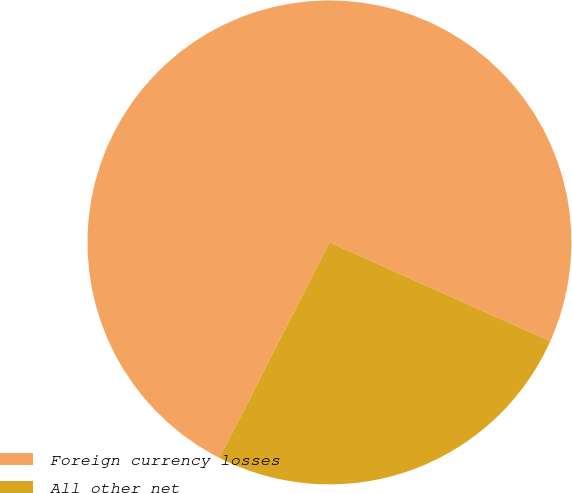<chart> <loc_0><loc_0><loc_500><loc_500><pie_chart><fcel>Foreign currency losses<fcel>All other net<nl><fcel>74.18%<fcel>25.82%<nl></chart> 